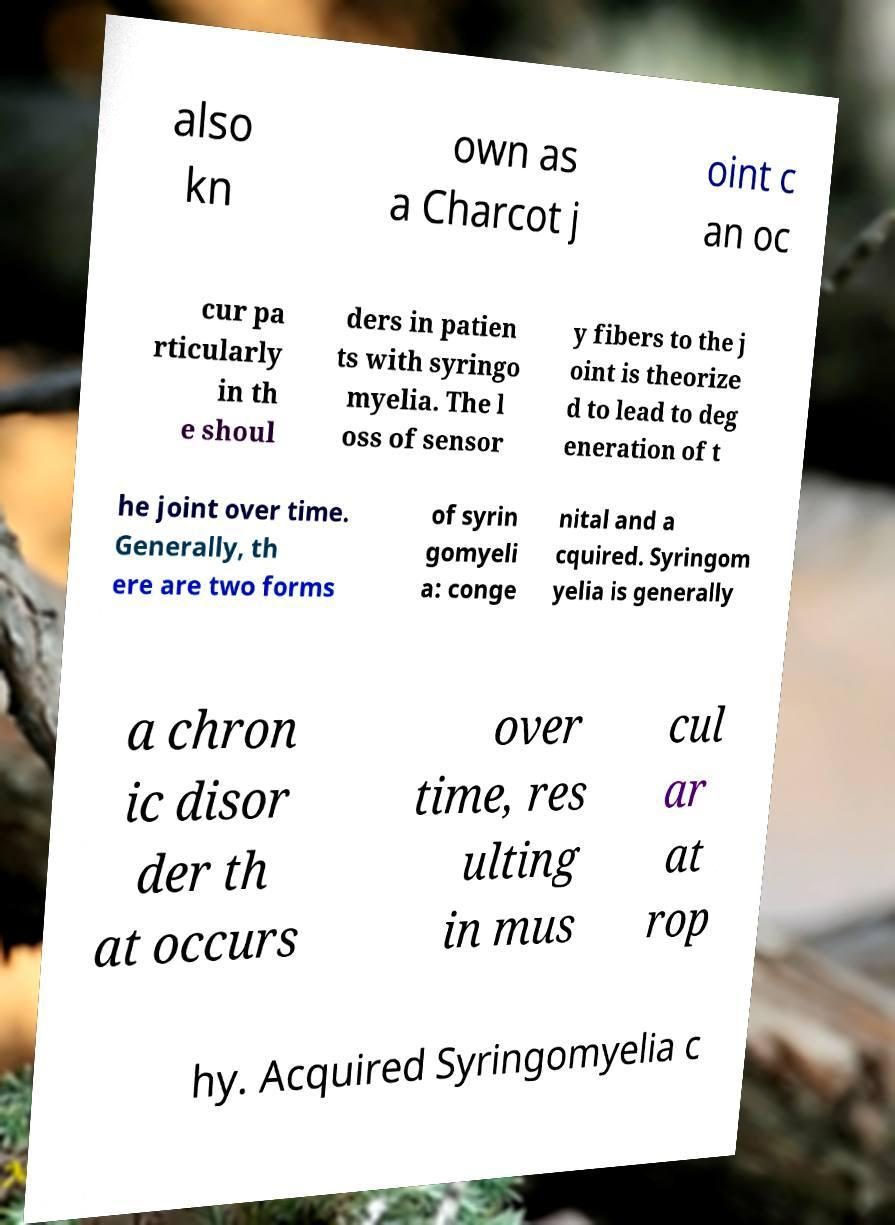Can you accurately transcribe the text from the provided image for me? also kn own as a Charcot j oint c an oc cur pa rticularly in th e shoul ders in patien ts with syringo myelia. The l oss of sensor y fibers to the j oint is theorize d to lead to deg eneration of t he joint over time. Generally, th ere are two forms of syrin gomyeli a: conge nital and a cquired. Syringom yelia is generally a chron ic disor der th at occurs over time, res ulting in mus cul ar at rop hy. Acquired Syringomyelia c 